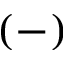<formula> <loc_0><loc_0><loc_500><loc_500>( - )</formula> 